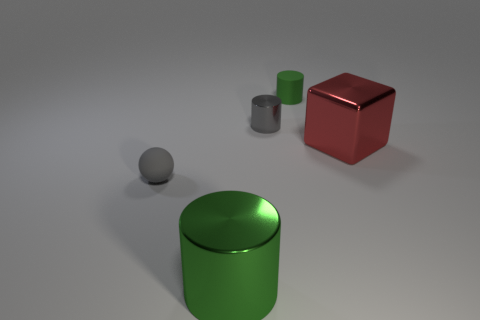Add 3 tiny yellow cubes. How many objects exist? 8 Subtract all balls. How many objects are left? 4 Subtract all metallic cubes. Subtract all small rubber spheres. How many objects are left? 3 Add 1 red cubes. How many red cubes are left? 2 Add 5 large matte cylinders. How many large matte cylinders exist? 5 Subtract 0 yellow spheres. How many objects are left? 5 